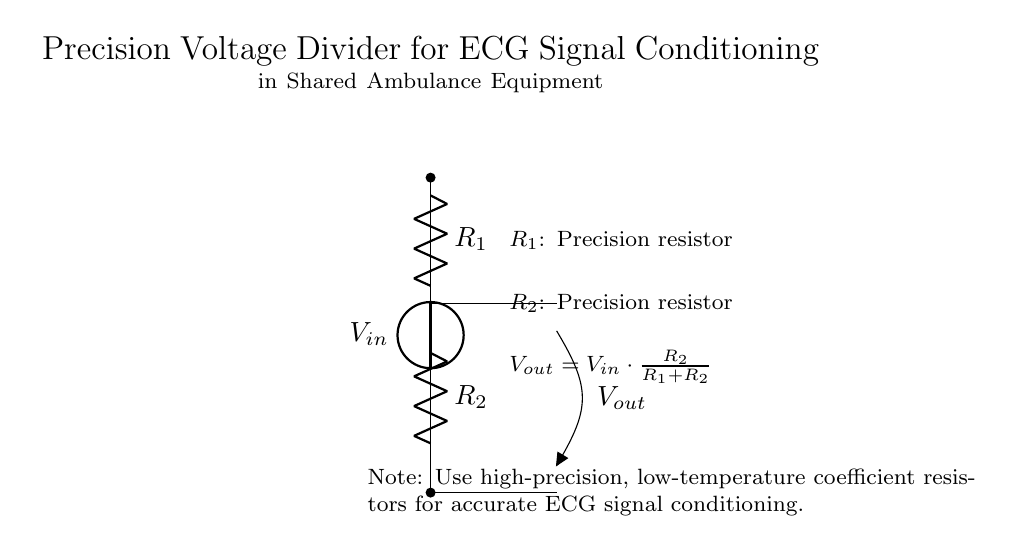What type of circuit is depicted? The diagram shows a voltage divider circuit, which is characterized by two resistors arranged in series, where the output voltage is taken from the junction of the two resistors.
Answer: Voltage divider What are the values of the resistors used? The circuit specifies that both resistors are precision resistors, but the exact numerical values are not given in the diagram. Their specific resistance values would be determined based on the design requirements for the ECG signal conditioning.
Answer: Precision resistors What is the output voltage formula provided? The output voltage formula is displayed under the circuit, which shows how the output voltage is calculated based on the input voltage and the resistor values. The formula is: Vout = Vin · (R2 / (R1 + R2)).
Answer: Vout = Vin · (R2 / (R1 + R2)) Why should high-precision resistors be used? High-precision, low-temperature coefficient resistors are recommended to ensure that the resistance values remain stable and accurate, which is critical for maintaining the integrity of the ECG signal during measurement and conditioning processes.
Answer: To maintain accuracy How does increasing R1 affect Vout? Increasing R1 while keeping R2 constant will increase the total resistance in the denominator, thus decreasing Vout, as seen in the voltage divider formula. This reflects the inverse relationship between R1 and Vout in the circuit.
Answer: Vout decreases Which component connects to Vin? The component connected to Vin is the voltage source indicated at the top of the circuit diagram. It supplies the input voltage needed for the operation of the voltage divider.
Answer: Voltage source 